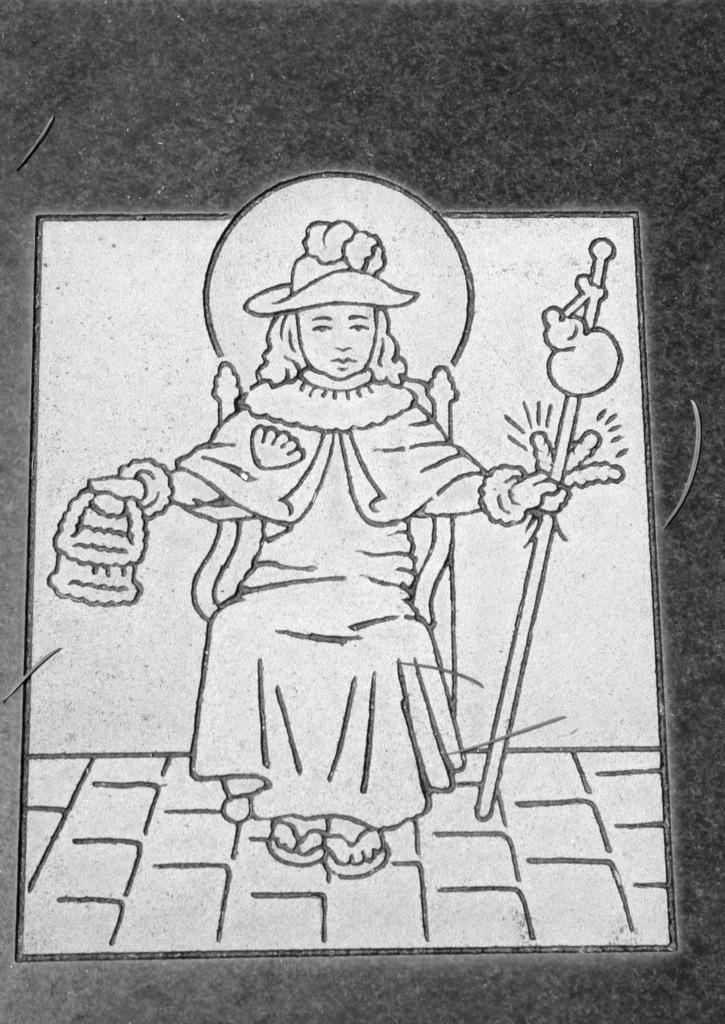Can you describe this image briefly? In this image there is a drawing of a person, the person is sitting in the chair, the person is holding objects, the background of the person is white in color, the background of the image is dark. 